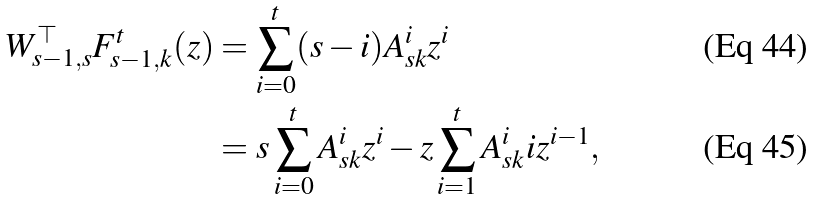Convert formula to latex. <formula><loc_0><loc_0><loc_500><loc_500>W _ { s - 1 , s } ^ { \top } F ^ { t } _ { s - 1 , k } ( z ) & = \sum _ { i = 0 } ^ { t } ( s - i ) A _ { s k } ^ { i } z ^ { i } \\ & = s \sum _ { i = 0 } ^ { t } A _ { s k } ^ { i } z ^ { i } - z \sum _ { i = 1 } ^ { t } A _ { s k } ^ { i } i z ^ { i - 1 } ,</formula> 